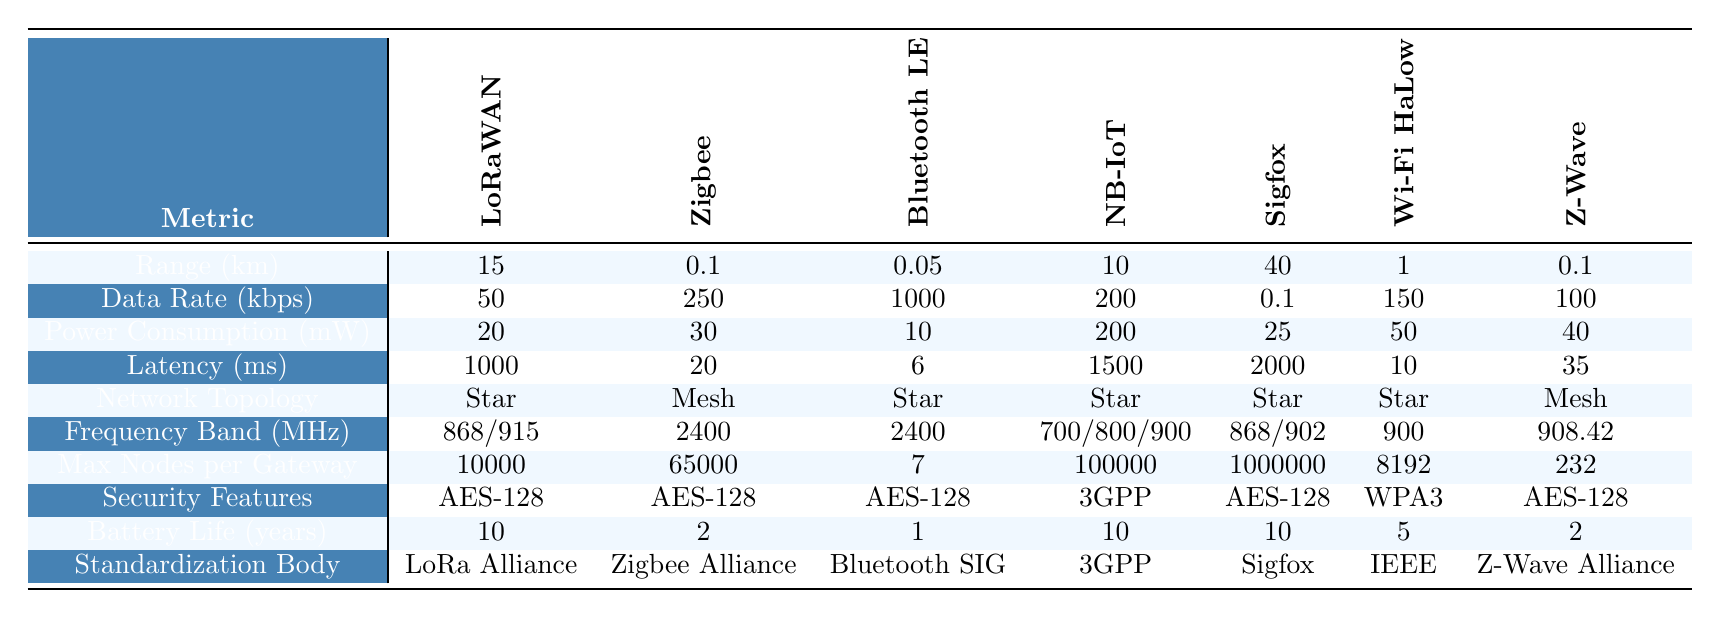What is the maximum range of the wireless protocols listed? The maximum range can be found by scanning the "Range (km)" row in the table. The maximum value is 40 km, which belongs to the Sigfox protocol.
Answer: 40 km Which protocol has the lowest power consumption? By looking at the "Power Consumption (mW)" row, Bluetooth Low Energy has the lowest value at 10 mW.
Answer: 10 mW What is the average battery life of the listed protocols? To find the average battery life, add the battery life values (10 + 2 + 1 + 10 + 10 + 5 + 2 = 40) and divide by the total number of protocols (7). The average is 40/7 ≈ 5.71 years.
Answer: Approximately 5.71 years Which wireless protocol has the highest data rate, and what is that rate? The "Data Rate (kbps)" row shows that Bluetooth Low Energy has the highest data rate of 1000 kbps.
Answer: 1000 kbps Is Zigbee ranked first for maximum nodes per gateway? By checking the "Max Nodes per Gateway" row, Zigbee has 65000 nodes, which is not the highest; Sigfox has 1000000 nodes. Therefore, Zigbee is not ranked first.
Answer: No What is the difference in latency between NB-IoT and Wi-Fi HaLow? To find the difference, subtract the latency of Wi-Fi HaLow (10 ms) from that of NB-IoT (1500 ms). The difference is 1500 - 10 = 1490 ms.
Answer: 1490 ms Which protocols utilize the AES-128 security feature? By examining the "Security Features" row, the protocols using AES-128 are LoRaWAN, Zigbee, Sigfox, and Z-Wave.
Answer: LoRaWAN, Zigbee, Sigfox, Z-Wave How many protocols have a battery life of at least 5 years? Checking the "Battery Life (years)" row, LoRaWAN (10), Sigfox (10), and Wi-Fi HaLow (5) all have battery lives of 5 years or more. Thus, there are 3 such protocols.
Answer: 3 What is the frequency range of the protocol with the second highest maximum nodes per gateway? The protocol with the second highest max nodes per gateway is NB-IoT with 100000 nodes, and its frequency band is 700/800/900 MHz.
Answer: 700/800/900 MHz Which protocol has the highest latency and what is that value? Referring to the "Latency (ms)" row, Sigfox has the highest latency at 2000 ms.
Answer: 2000 ms Does the protocol Wi-Fi HaLow support mesh topology? Looking at the "Network Topology" row, Wi-Fi HaLow follows a star topology, not a mesh topology, so the answer is no.
Answer: No 